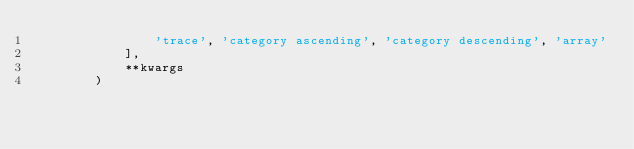Convert code to text. <code><loc_0><loc_0><loc_500><loc_500><_Python_>                'trace', 'category ascending', 'category descending', 'array'
            ],
            **kwargs
        )
</code> 